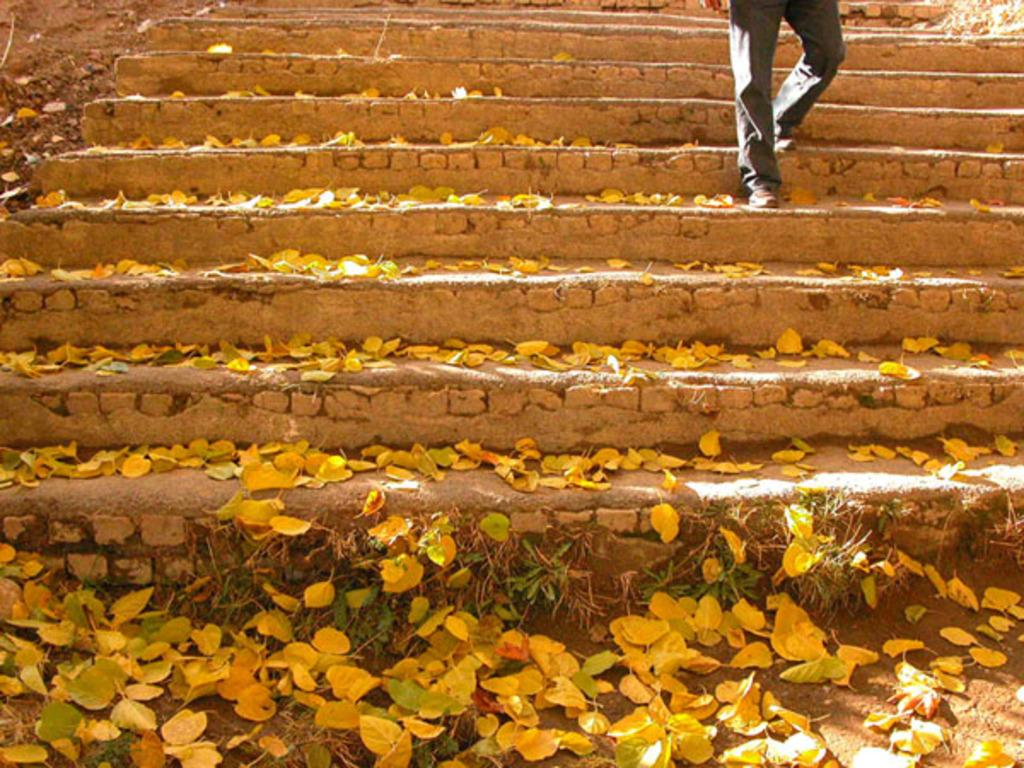What type of structure is present in the image? There are stairs in the image. Can you describe the position of the person in the image? A person is standing on the stairs. What can be observed about the surroundings in the image? There are yellow-colored leaves visible in the image. What type of memory is being stored in the iron on the stairs? There is no iron or memory storage device present in the image; it only features stairs and a person standing on them. 